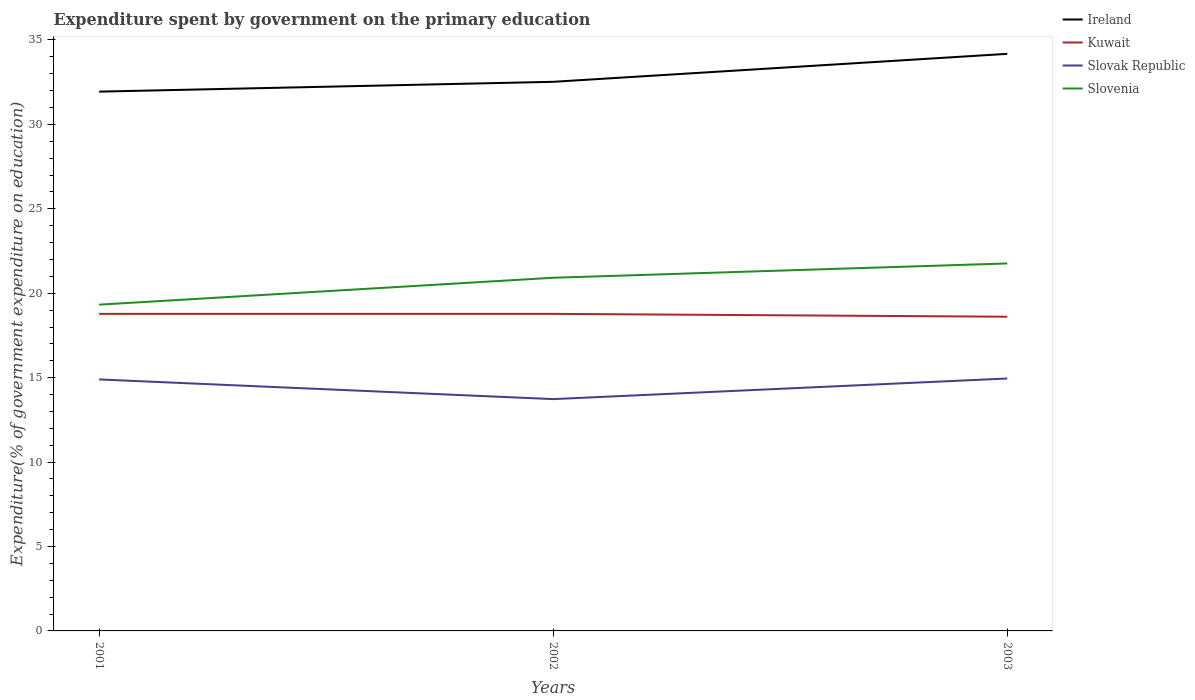How many different coloured lines are there?
Make the answer very short. 4. Does the line corresponding to Kuwait intersect with the line corresponding to Slovenia?
Your answer should be compact. No. Is the number of lines equal to the number of legend labels?
Your answer should be compact. Yes. Across all years, what is the maximum expenditure spent by government on the primary education in Slovak Republic?
Keep it short and to the point. 13.73. What is the total expenditure spent by government on the primary education in Slovenia in the graph?
Keep it short and to the point. -1.59. What is the difference between the highest and the second highest expenditure spent by government on the primary education in Slovak Republic?
Make the answer very short. 1.22. Is the expenditure spent by government on the primary education in Ireland strictly greater than the expenditure spent by government on the primary education in Slovenia over the years?
Keep it short and to the point. No. How many lines are there?
Ensure brevity in your answer.  4. Does the graph contain grids?
Ensure brevity in your answer.  No. How many legend labels are there?
Offer a terse response. 4. How are the legend labels stacked?
Ensure brevity in your answer.  Vertical. What is the title of the graph?
Make the answer very short. Expenditure spent by government on the primary education. What is the label or title of the Y-axis?
Your response must be concise. Expenditure(% of government expenditure on education). What is the Expenditure(% of government expenditure on education) in Ireland in 2001?
Your answer should be compact. 31.94. What is the Expenditure(% of government expenditure on education) of Kuwait in 2001?
Your answer should be very brief. 18.78. What is the Expenditure(% of government expenditure on education) in Slovak Republic in 2001?
Offer a terse response. 14.89. What is the Expenditure(% of government expenditure on education) in Slovenia in 2001?
Give a very brief answer. 19.32. What is the Expenditure(% of government expenditure on education) of Ireland in 2002?
Ensure brevity in your answer.  32.52. What is the Expenditure(% of government expenditure on education) of Kuwait in 2002?
Ensure brevity in your answer.  18.78. What is the Expenditure(% of government expenditure on education) of Slovak Republic in 2002?
Offer a terse response. 13.73. What is the Expenditure(% of government expenditure on education) in Slovenia in 2002?
Your response must be concise. 20.92. What is the Expenditure(% of government expenditure on education) of Ireland in 2003?
Your answer should be very brief. 34.18. What is the Expenditure(% of government expenditure on education) of Kuwait in 2003?
Ensure brevity in your answer.  18.61. What is the Expenditure(% of government expenditure on education) of Slovak Republic in 2003?
Offer a terse response. 14.95. What is the Expenditure(% of government expenditure on education) of Slovenia in 2003?
Keep it short and to the point. 21.76. Across all years, what is the maximum Expenditure(% of government expenditure on education) of Ireland?
Give a very brief answer. 34.18. Across all years, what is the maximum Expenditure(% of government expenditure on education) of Kuwait?
Provide a short and direct response. 18.78. Across all years, what is the maximum Expenditure(% of government expenditure on education) of Slovak Republic?
Keep it short and to the point. 14.95. Across all years, what is the maximum Expenditure(% of government expenditure on education) in Slovenia?
Offer a very short reply. 21.76. Across all years, what is the minimum Expenditure(% of government expenditure on education) of Ireland?
Make the answer very short. 31.94. Across all years, what is the minimum Expenditure(% of government expenditure on education) in Kuwait?
Ensure brevity in your answer.  18.61. Across all years, what is the minimum Expenditure(% of government expenditure on education) in Slovak Republic?
Keep it short and to the point. 13.73. Across all years, what is the minimum Expenditure(% of government expenditure on education) of Slovenia?
Provide a short and direct response. 19.32. What is the total Expenditure(% of government expenditure on education) in Ireland in the graph?
Give a very brief answer. 98.64. What is the total Expenditure(% of government expenditure on education) of Kuwait in the graph?
Keep it short and to the point. 56.17. What is the total Expenditure(% of government expenditure on education) in Slovak Republic in the graph?
Offer a terse response. 43.57. What is the total Expenditure(% of government expenditure on education) in Slovenia in the graph?
Your answer should be compact. 62. What is the difference between the Expenditure(% of government expenditure on education) of Ireland in 2001 and that in 2002?
Provide a succinct answer. -0.58. What is the difference between the Expenditure(% of government expenditure on education) in Kuwait in 2001 and that in 2002?
Make the answer very short. 0. What is the difference between the Expenditure(% of government expenditure on education) of Slovak Republic in 2001 and that in 2002?
Provide a succinct answer. 1.16. What is the difference between the Expenditure(% of government expenditure on education) in Slovenia in 2001 and that in 2002?
Provide a short and direct response. -1.59. What is the difference between the Expenditure(% of government expenditure on education) in Ireland in 2001 and that in 2003?
Your answer should be compact. -2.24. What is the difference between the Expenditure(% of government expenditure on education) of Kuwait in 2001 and that in 2003?
Offer a very short reply. 0.17. What is the difference between the Expenditure(% of government expenditure on education) in Slovak Republic in 2001 and that in 2003?
Provide a succinct answer. -0.06. What is the difference between the Expenditure(% of government expenditure on education) in Slovenia in 2001 and that in 2003?
Your answer should be very brief. -2.44. What is the difference between the Expenditure(% of government expenditure on education) in Ireland in 2002 and that in 2003?
Offer a terse response. -1.66. What is the difference between the Expenditure(% of government expenditure on education) of Kuwait in 2002 and that in 2003?
Keep it short and to the point. 0.17. What is the difference between the Expenditure(% of government expenditure on education) in Slovak Republic in 2002 and that in 2003?
Your answer should be very brief. -1.22. What is the difference between the Expenditure(% of government expenditure on education) in Slovenia in 2002 and that in 2003?
Make the answer very short. -0.85. What is the difference between the Expenditure(% of government expenditure on education) of Ireland in 2001 and the Expenditure(% of government expenditure on education) of Kuwait in 2002?
Provide a short and direct response. 13.16. What is the difference between the Expenditure(% of government expenditure on education) of Ireland in 2001 and the Expenditure(% of government expenditure on education) of Slovak Republic in 2002?
Provide a succinct answer. 18.21. What is the difference between the Expenditure(% of government expenditure on education) of Ireland in 2001 and the Expenditure(% of government expenditure on education) of Slovenia in 2002?
Keep it short and to the point. 11.02. What is the difference between the Expenditure(% of government expenditure on education) of Kuwait in 2001 and the Expenditure(% of government expenditure on education) of Slovak Republic in 2002?
Ensure brevity in your answer.  5.05. What is the difference between the Expenditure(% of government expenditure on education) in Kuwait in 2001 and the Expenditure(% of government expenditure on education) in Slovenia in 2002?
Your answer should be very brief. -2.14. What is the difference between the Expenditure(% of government expenditure on education) in Slovak Republic in 2001 and the Expenditure(% of government expenditure on education) in Slovenia in 2002?
Give a very brief answer. -6.02. What is the difference between the Expenditure(% of government expenditure on education) in Ireland in 2001 and the Expenditure(% of government expenditure on education) in Kuwait in 2003?
Give a very brief answer. 13.33. What is the difference between the Expenditure(% of government expenditure on education) of Ireland in 2001 and the Expenditure(% of government expenditure on education) of Slovak Republic in 2003?
Provide a short and direct response. 16.99. What is the difference between the Expenditure(% of government expenditure on education) of Ireland in 2001 and the Expenditure(% of government expenditure on education) of Slovenia in 2003?
Provide a short and direct response. 10.18. What is the difference between the Expenditure(% of government expenditure on education) in Kuwait in 2001 and the Expenditure(% of government expenditure on education) in Slovak Republic in 2003?
Offer a terse response. 3.83. What is the difference between the Expenditure(% of government expenditure on education) in Kuwait in 2001 and the Expenditure(% of government expenditure on education) in Slovenia in 2003?
Your response must be concise. -2.98. What is the difference between the Expenditure(% of government expenditure on education) in Slovak Republic in 2001 and the Expenditure(% of government expenditure on education) in Slovenia in 2003?
Give a very brief answer. -6.87. What is the difference between the Expenditure(% of government expenditure on education) of Ireland in 2002 and the Expenditure(% of government expenditure on education) of Kuwait in 2003?
Your response must be concise. 13.91. What is the difference between the Expenditure(% of government expenditure on education) in Ireland in 2002 and the Expenditure(% of government expenditure on education) in Slovak Republic in 2003?
Your response must be concise. 17.57. What is the difference between the Expenditure(% of government expenditure on education) in Ireland in 2002 and the Expenditure(% of government expenditure on education) in Slovenia in 2003?
Your answer should be compact. 10.76. What is the difference between the Expenditure(% of government expenditure on education) in Kuwait in 2002 and the Expenditure(% of government expenditure on education) in Slovak Republic in 2003?
Your response must be concise. 3.83. What is the difference between the Expenditure(% of government expenditure on education) in Kuwait in 2002 and the Expenditure(% of government expenditure on education) in Slovenia in 2003?
Your answer should be very brief. -2.98. What is the difference between the Expenditure(% of government expenditure on education) of Slovak Republic in 2002 and the Expenditure(% of government expenditure on education) of Slovenia in 2003?
Offer a terse response. -8.03. What is the average Expenditure(% of government expenditure on education) of Ireland per year?
Make the answer very short. 32.88. What is the average Expenditure(% of government expenditure on education) in Kuwait per year?
Your response must be concise. 18.72. What is the average Expenditure(% of government expenditure on education) in Slovak Republic per year?
Keep it short and to the point. 14.52. What is the average Expenditure(% of government expenditure on education) of Slovenia per year?
Your answer should be compact. 20.67. In the year 2001, what is the difference between the Expenditure(% of government expenditure on education) of Ireland and Expenditure(% of government expenditure on education) of Kuwait?
Offer a terse response. 13.16. In the year 2001, what is the difference between the Expenditure(% of government expenditure on education) of Ireland and Expenditure(% of government expenditure on education) of Slovak Republic?
Offer a very short reply. 17.05. In the year 2001, what is the difference between the Expenditure(% of government expenditure on education) of Ireland and Expenditure(% of government expenditure on education) of Slovenia?
Give a very brief answer. 12.62. In the year 2001, what is the difference between the Expenditure(% of government expenditure on education) of Kuwait and Expenditure(% of government expenditure on education) of Slovak Republic?
Provide a succinct answer. 3.88. In the year 2001, what is the difference between the Expenditure(% of government expenditure on education) in Kuwait and Expenditure(% of government expenditure on education) in Slovenia?
Your answer should be compact. -0.55. In the year 2001, what is the difference between the Expenditure(% of government expenditure on education) in Slovak Republic and Expenditure(% of government expenditure on education) in Slovenia?
Your answer should be very brief. -4.43. In the year 2002, what is the difference between the Expenditure(% of government expenditure on education) of Ireland and Expenditure(% of government expenditure on education) of Kuwait?
Give a very brief answer. 13.74. In the year 2002, what is the difference between the Expenditure(% of government expenditure on education) in Ireland and Expenditure(% of government expenditure on education) in Slovak Republic?
Provide a short and direct response. 18.79. In the year 2002, what is the difference between the Expenditure(% of government expenditure on education) in Ireland and Expenditure(% of government expenditure on education) in Slovenia?
Your answer should be very brief. 11.6. In the year 2002, what is the difference between the Expenditure(% of government expenditure on education) of Kuwait and Expenditure(% of government expenditure on education) of Slovak Republic?
Provide a short and direct response. 5.05. In the year 2002, what is the difference between the Expenditure(% of government expenditure on education) of Kuwait and Expenditure(% of government expenditure on education) of Slovenia?
Your answer should be very brief. -2.14. In the year 2002, what is the difference between the Expenditure(% of government expenditure on education) of Slovak Republic and Expenditure(% of government expenditure on education) of Slovenia?
Ensure brevity in your answer.  -7.19. In the year 2003, what is the difference between the Expenditure(% of government expenditure on education) of Ireland and Expenditure(% of government expenditure on education) of Kuwait?
Ensure brevity in your answer.  15.57. In the year 2003, what is the difference between the Expenditure(% of government expenditure on education) in Ireland and Expenditure(% of government expenditure on education) in Slovak Republic?
Your answer should be compact. 19.23. In the year 2003, what is the difference between the Expenditure(% of government expenditure on education) in Ireland and Expenditure(% of government expenditure on education) in Slovenia?
Provide a short and direct response. 12.42. In the year 2003, what is the difference between the Expenditure(% of government expenditure on education) in Kuwait and Expenditure(% of government expenditure on education) in Slovak Republic?
Offer a very short reply. 3.66. In the year 2003, what is the difference between the Expenditure(% of government expenditure on education) in Kuwait and Expenditure(% of government expenditure on education) in Slovenia?
Offer a very short reply. -3.15. In the year 2003, what is the difference between the Expenditure(% of government expenditure on education) of Slovak Republic and Expenditure(% of government expenditure on education) of Slovenia?
Make the answer very short. -6.81. What is the ratio of the Expenditure(% of government expenditure on education) of Ireland in 2001 to that in 2002?
Your answer should be compact. 0.98. What is the ratio of the Expenditure(% of government expenditure on education) in Kuwait in 2001 to that in 2002?
Provide a succinct answer. 1. What is the ratio of the Expenditure(% of government expenditure on education) of Slovak Republic in 2001 to that in 2002?
Make the answer very short. 1.08. What is the ratio of the Expenditure(% of government expenditure on education) of Slovenia in 2001 to that in 2002?
Ensure brevity in your answer.  0.92. What is the ratio of the Expenditure(% of government expenditure on education) of Ireland in 2001 to that in 2003?
Keep it short and to the point. 0.93. What is the ratio of the Expenditure(% of government expenditure on education) in Kuwait in 2001 to that in 2003?
Provide a short and direct response. 1.01. What is the ratio of the Expenditure(% of government expenditure on education) in Slovenia in 2001 to that in 2003?
Ensure brevity in your answer.  0.89. What is the ratio of the Expenditure(% of government expenditure on education) of Ireland in 2002 to that in 2003?
Offer a very short reply. 0.95. What is the ratio of the Expenditure(% of government expenditure on education) of Kuwait in 2002 to that in 2003?
Offer a terse response. 1.01. What is the ratio of the Expenditure(% of government expenditure on education) in Slovak Republic in 2002 to that in 2003?
Give a very brief answer. 0.92. What is the ratio of the Expenditure(% of government expenditure on education) of Slovenia in 2002 to that in 2003?
Make the answer very short. 0.96. What is the difference between the highest and the second highest Expenditure(% of government expenditure on education) of Ireland?
Give a very brief answer. 1.66. What is the difference between the highest and the second highest Expenditure(% of government expenditure on education) of Kuwait?
Give a very brief answer. 0. What is the difference between the highest and the second highest Expenditure(% of government expenditure on education) in Slovak Republic?
Your response must be concise. 0.06. What is the difference between the highest and the second highest Expenditure(% of government expenditure on education) of Slovenia?
Make the answer very short. 0.85. What is the difference between the highest and the lowest Expenditure(% of government expenditure on education) in Ireland?
Offer a terse response. 2.24. What is the difference between the highest and the lowest Expenditure(% of government expenditure on education) in Kuwait?
Your answer should be very brief. 0.17. What is the difference between the highest and the lowest Expenditure(% of government expenditure on education) of Slovak Republic?
Offer a terse response. 1.22. What is the difference between the highest and the lowest Expenditure(% of government expenditure on education) of Slovenia?
Your answer should be very brief. 2.44. 